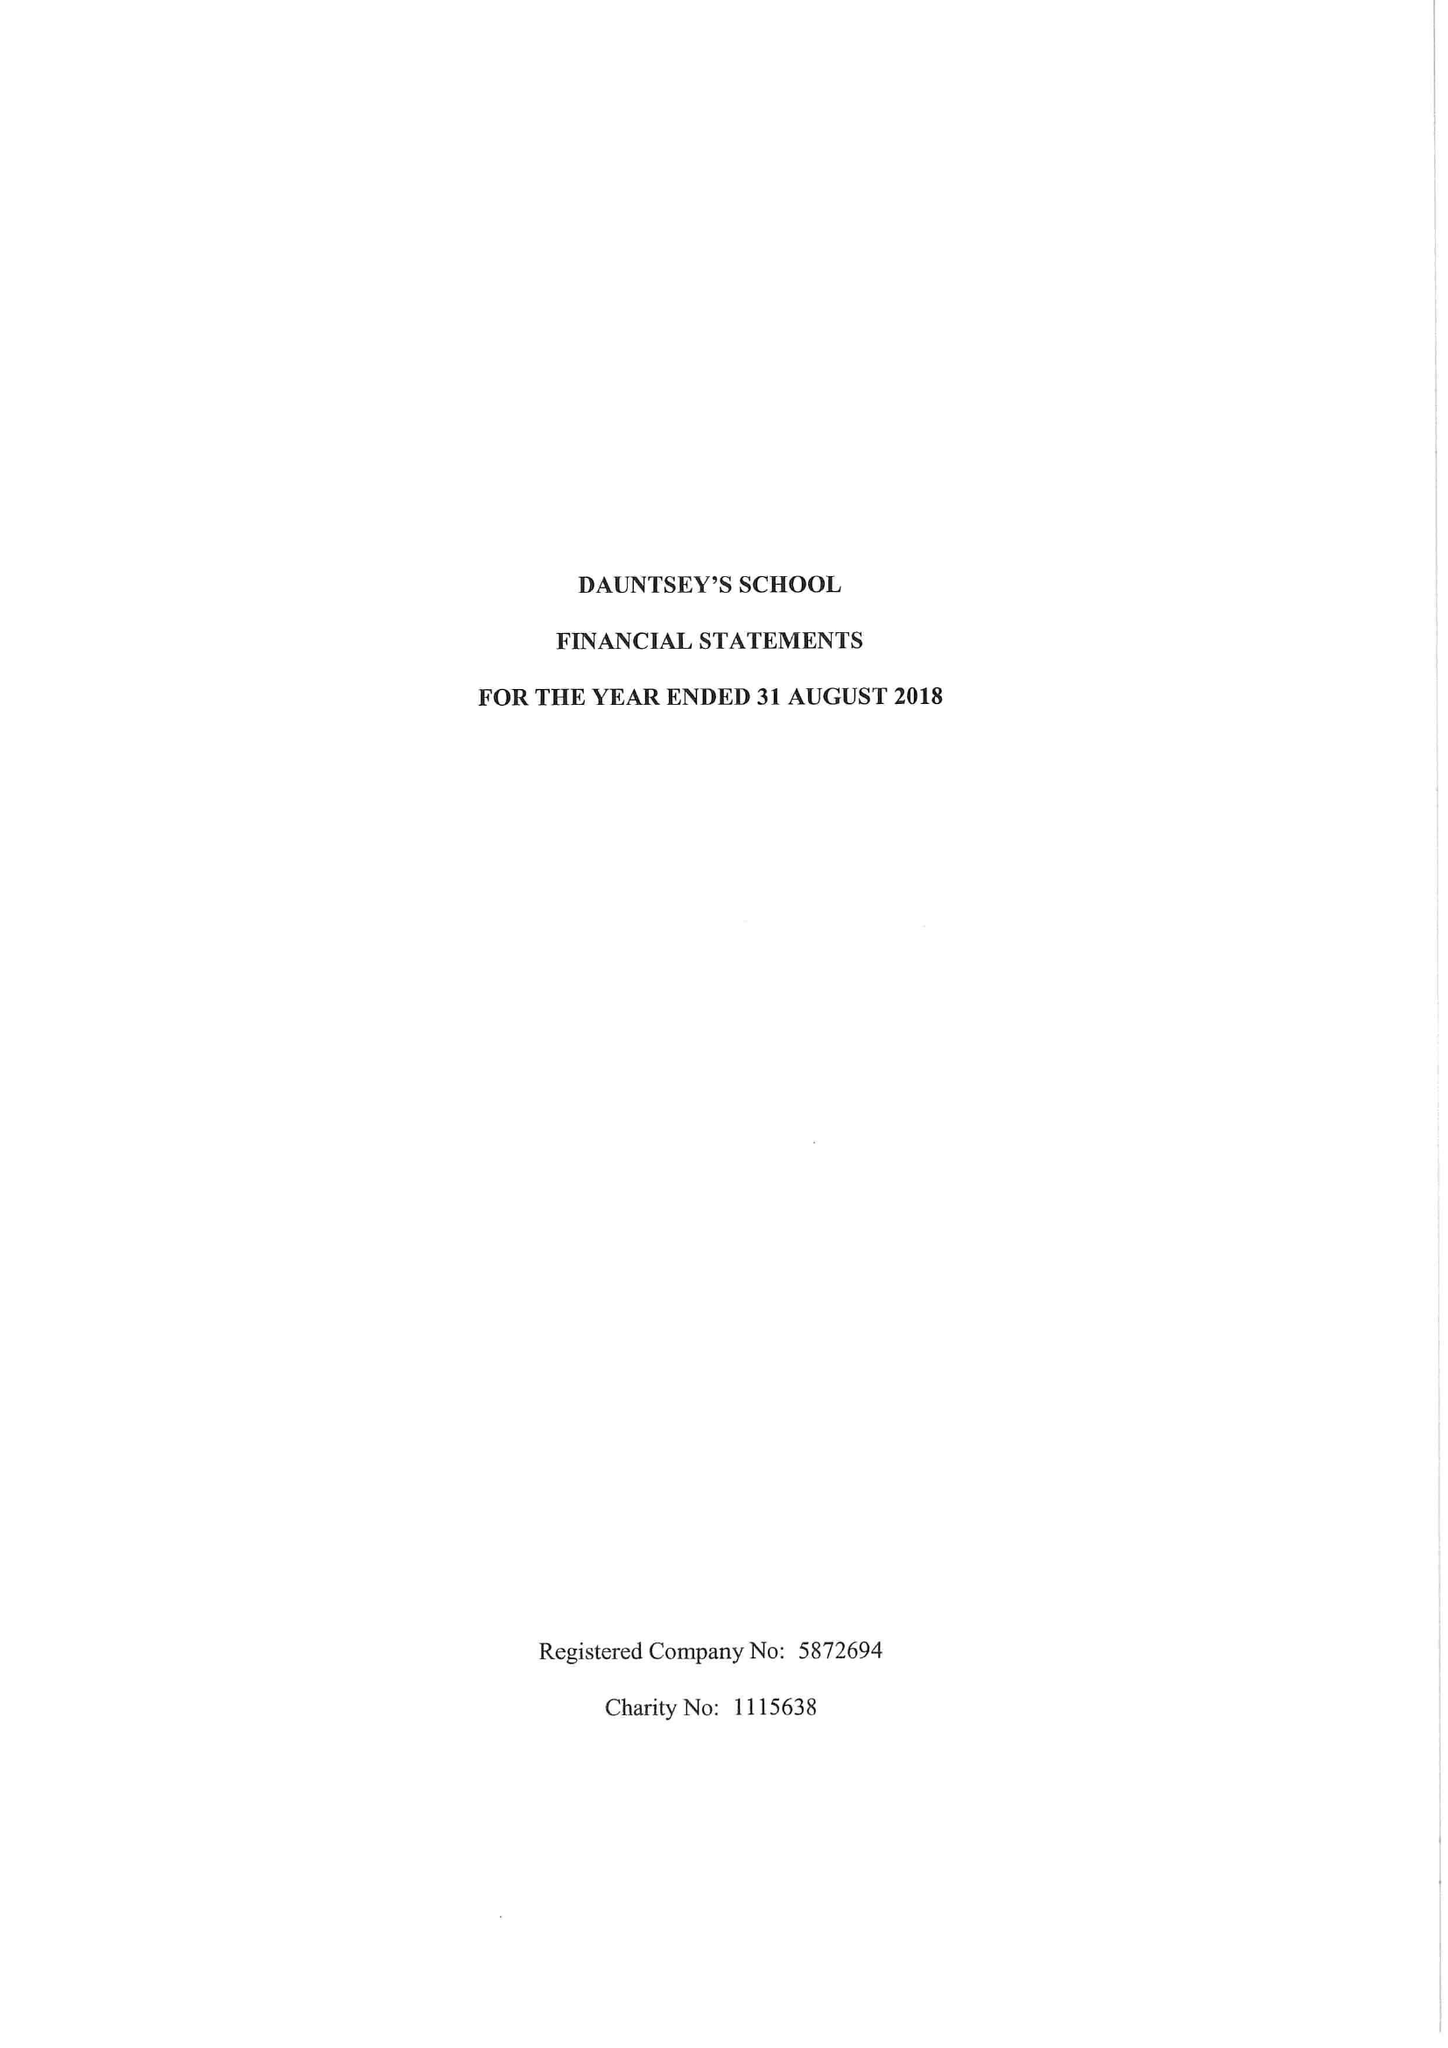What is the value for the address__postcode?
Answer the question using a single word or phrase. SN10 4HE 